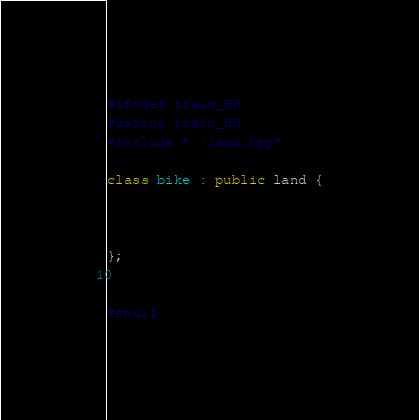Convert code to text. <code><loc_0><loc_0><loc_500><loc_500><_C++_>#ifndef train_HH
#define train_HH
#include "./land.hpp"

class bike : public land {



};


#endif</code> 